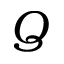<formula> <loc_0><loc_0><loc_500><loc_500>Q</formula> 